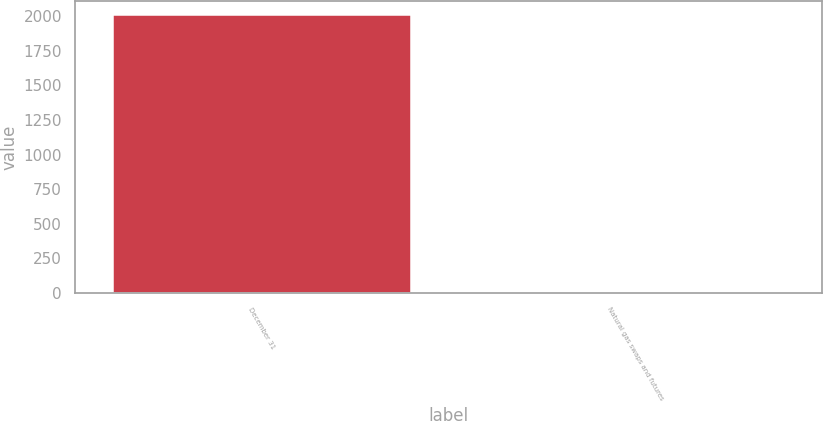Convert chart. <chart><loc_0><loc_0><loc_500><loc_500><bar_chart><fcel>December 31<fcel>Natural gas swaps and futures<nl><fcel>2008<fcel>1<nl></chart> 